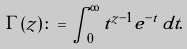Convert formula to latex. <formula><loc_0><loc_0><loc_500><loc_500>\Gamma ( z ) \colon = \int _ { 0 } ^ { \infty } t ^ { z - 1 } e ^ { - t } \, d t .</formula> 